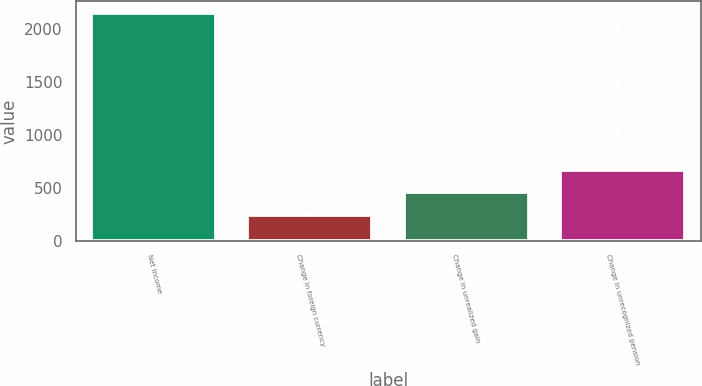Convert chart to OTSL. <chart><loc_0><loc_0><loc_500><loc_500><bar_chart><fcel>Net income<fcel>Change in foreign currency<fcel>Change in unrealized gain<fcel>Change in unrecognized pension<nl><fcel>2152<fcel>244.9<fcel>456.8<fcel>668.7<nl></chart> 